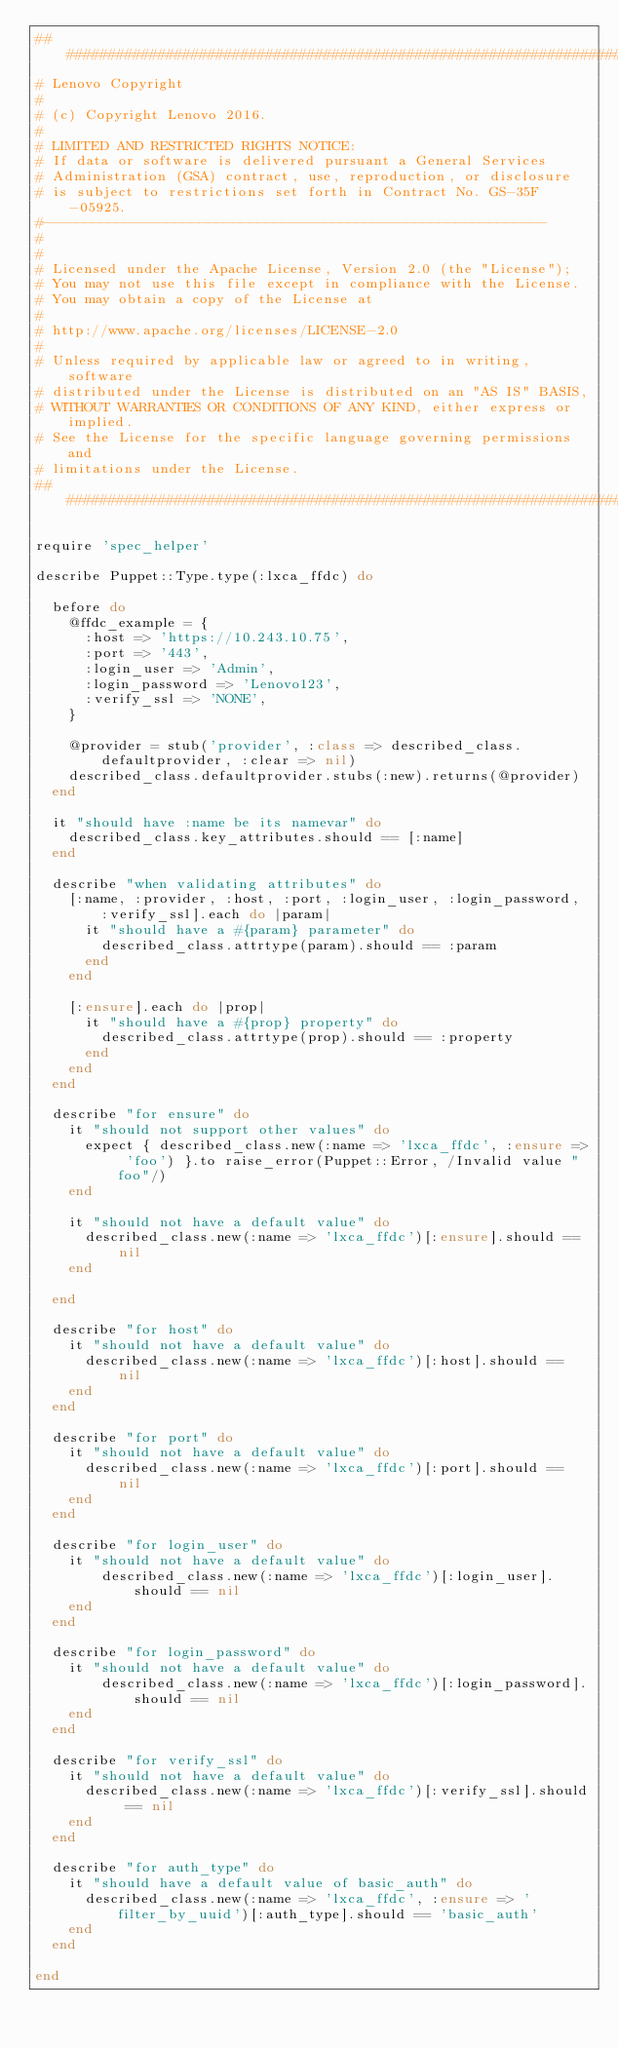<code> <loc_0><loc_0><loc_500><loc_500><_Ruby_>################################################################################
# Lenovo Copyright
#
# (c) Copyright Lenovo 2016.
#
# LIMITED AND RESTRICTED RIGHTS NOTICE:
# If data or software is delivered pursuant a General Services
# Administration (GSA) contract, use, reproduction, or disclosure
# is subject to restrictions set forth in Contract No. GS-35F-05925.
#-------------------------------------------------------------
#
#
# Licensed under the Apache License, Version 2.0 (the "License");
# You may not use this file except in compliance with the License.
# You may obtain a copy of the License at
#
# http://www.apache.org/licenses/LICENSE-2.0
#
# Unless required by applicable law or agreed to in writing, software
# distributed under the License is distributed on an "AS IS" BASIS,
# WITHOUT WARRANTIES OR CONDITIONS OF ANY KIND, either express or implied.
# See the License for the specific language governing permissions and
# limitations under the License.
################################################################################

require 'spec_helper'

describe Puppet::Type.type(:lxca_ffdc) do

  before do
    @ffdc_example = {
      :host => 'https://10.243.10.75',
      :port => '443',
      :login_user => 'Admin',
      :login_password => 'Lenovo123',
      :verify_ssl => 'NONE',
    }
   
    @provider = stub('provider', :class => described_class.defaultprovider, :clear => nil)
    described_class.defaultprovider.stubs(:new).returns(@provider)
  end

  it "should have :name be its namevar" do
    described_class.key_attributes.should == [:name]
  end

  describe "when validating attributes" do
    [:name, :provider, :host, :port, :login_user, :login_password, :verify_ssl].each do |param|
      it "should have a #{param} parameter" do
        described_class.attrtype(param).should == :param
      end
    end
  
    [:ensure].each do |prop|
      it "should have a #{prop} property" do
        described_class.attrtype(prop).should == :property
      end
    end
  end

  describe "for ensure" do
    it "should not support other values" do
      expect { described_class.new(:name => 'lxca_ffdc', :ensure => 'foo') }.to raise_error(Puppet::Error, /Invalid value "foo"/)
    end

    it "should not have a default value" do
      described_class.new(:name => 'lxca_ffdc')[:ensure].should == nil
    end
    
  end

  describe "for host" do
    it "should not have a default value" do
      described_class.new(:name => 'lxca_ffdc')[:host].should == nil
    end
  end

  describe "for port" do
    it "should not have a default value" do
      described_class.new(:name => 'lxca_ffdc')[:port].should == nil
    end
  end

  describe "for login_user" do
    it "should not have a default value" do
        described_class.new(:name => 'lxca_ffdc')[:login_user].should == nil
    end
  end

  describe "for login_password" do
    it "should not have a default value" do
        described_class.new(:name => 'lxca_ffdc')[:login_password].should == nil
    end
  end

  describe "for verify_ssl" do
    it "should not have a default value" do
      described_class.new(:name => 'lxca_ffdc')[:verify_ssl].should == nil
    end
  end

  describe "for auth_type" do
    it "should have a default value of basic_auth" do
      described_class.new(:name => 'lxca_ffdc', :ensure => 'filter_by_uuid')[:auth_type].should == 'basic_auth'
    end
  end

end 
</code> 